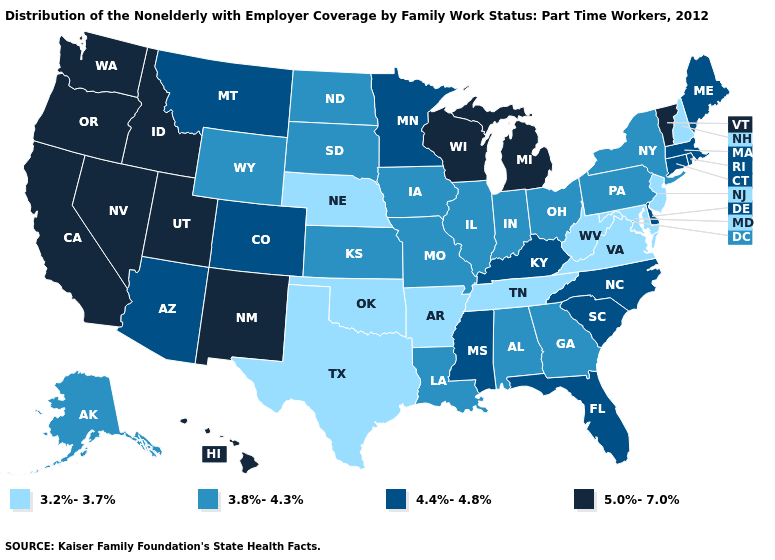Which states have the highest value in the USA?
Keep it brief. California, Hawaii, Idaho, Michigan, Nevada, New Mexico, Oregon, Utah, Vermont, Washington, Wisconsin. Name the states that have a value in the range 4.4%-4.8%?
Concise answer only. Arizona, Colorado, Connecticut, Delaware, Florida, Kentucky, Maine, Massachusetts, Minnesota, Mississippi, Montana, North Carolina, Rhode Island, South Carolina. What is the lowest value in the West?
Keep it brief. 3.8%-4.3%. What is the value of Florida?
Concise answer only. 4.4%-4.8%. Name the states that have a value in the range 3.8%-4.3%?
Write a very short answer. Alabama, Alaska, Georgia, Illinois, Indiana, Iowa, Kansas, Louisiana, Missouri, New York, North Dakota, Ohio, Pennsylvania, South Dakota, Wyoming. What is the lowest value in states that border Maryland?
Quick response, please. 3.2%-3.7%. Name the states that have a value in the range 5.0%-7.0%?
Write a very short answer. California, Hawaii, Idaho, Michigan, Nevada, New Mexico, Oregon, Utah, Vermont, Washington, Wisconsin. What is the value of Florida?
Write a very short answer. 4.4%-4.8%. What is the highest value in states that border Maine?
Write a very short answer. 3.2%-3.7%. What is the lowest value in the USA?
Keep it brief. 3.2%-3.7%. What is the lowest value in states that border California?
Be succinct. 4.4%-4.8%. How many symbols are there in the legend?
Give a very brief answer. 4. Does New Hampshire have the lowest value in the USA?
Give a very brief answer. Yes. Name the states that have a value in the range 4.4%-4.8%?
Short answer required. Arizona, Colorado, Connecticut, Delaware, Florida, Kentucky, Maine, Massachusetts, Minnesota, Mississippi, Montana, North Carolina, Rhode Island, South Carolina. Does the first symbol in the legend represent the smallest category?
Concise answer only. Yes. 